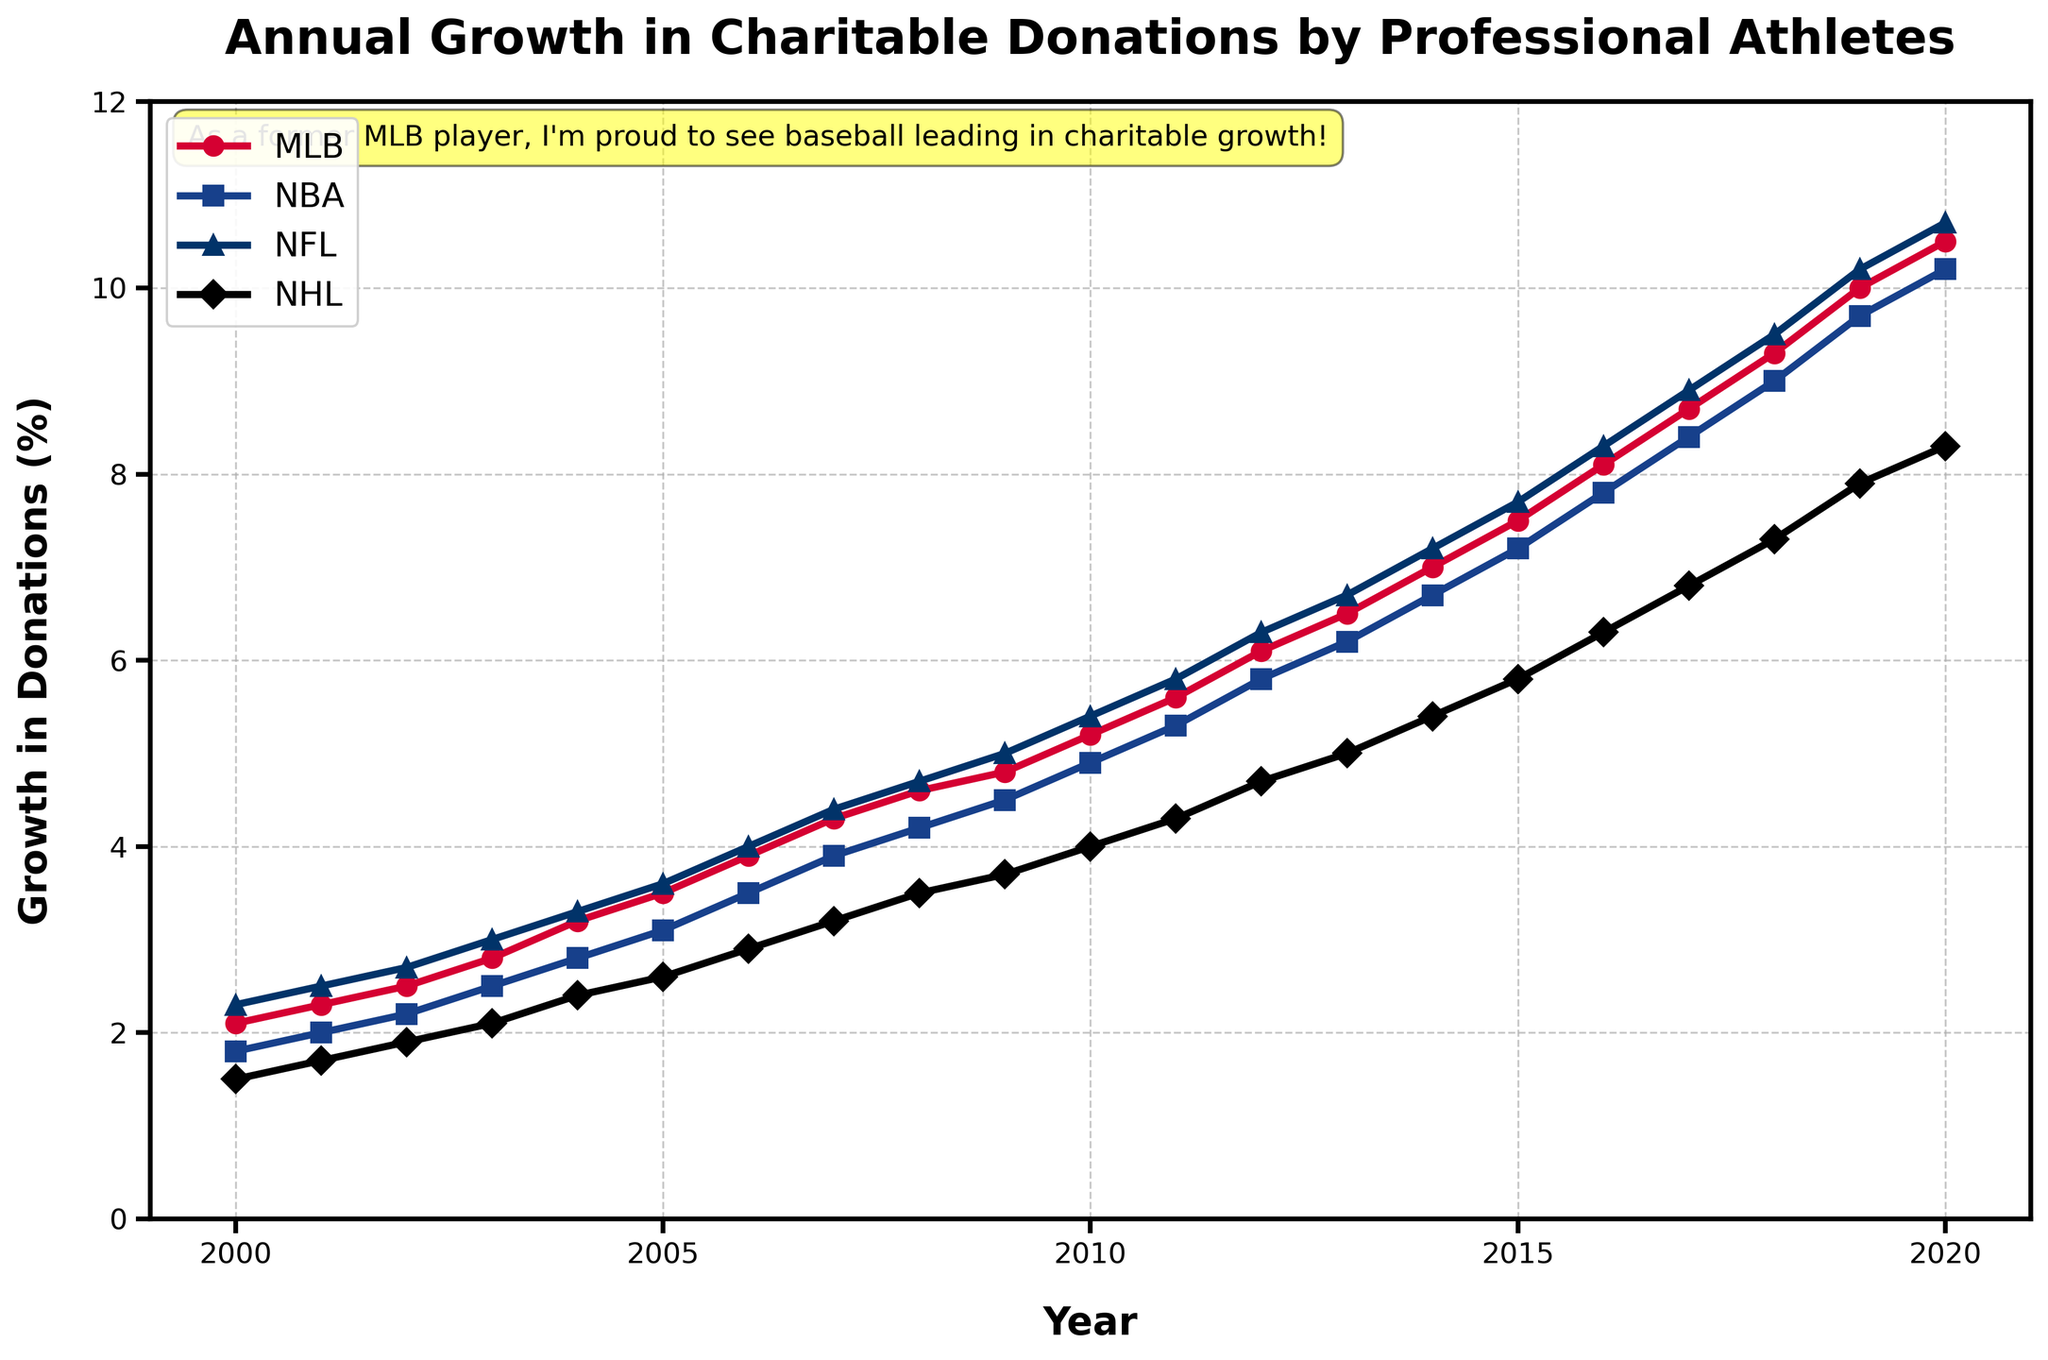what's the difference in charitable donations between MLB and NBA in 2020? To find the difference, subtract NBA's value from MLB's value in 2020. The MLB donations are 10.5% and NBA donations are 10.2%, so the difference is 10.5% - 10.2%.
Answer: 0.3% which league had the most significant growth in charitable donations from 2000 to 2020? Examine the difference between the 2020 value and the 2000 value for each league. MLB (10.5% - 2.1%), NBA (10.2% - 1.8%), NFL (10.7% - 2.3%), NHL (8.3% - 1.5%). The NFL has the highest growth.
Answer: NFL which two leagues had the closest donation growth percentages in 2010? Compare the donation values of all leagues in 2010. MLB (5.2%), NBA (4.9%), NFL (5.4%), NHL (4.0%). MLB and NFL have the closest percentages with a difference of 0.2%.
Answer: MLB and NFL what is the average growth in charitable donations for the NHL from 2000 to 2020? To find the average, sum up NHL's annual growth percentages from 2000 to 2020 and then divide by the number of years (21). (1.5+1.7+1.9+2.1+2.4+2.6+2.9+3.2+3.5+3.7+4.0+4.3+4.7+5.0+5.4+5.8+6.3+6.8+7.3+7.9+8.3)/21
Answer: 4.33 was there ever a year where the donation growth for all leagues crossed the 3% mark? Observe the lines for all leagues to see when they all pass the value of 3%. In the year 2005, the growth percentages for MLB, NBA, NFL, and NHL are 3.5%, 3.1%, 3.6%, and 2.6%, respectively. The closest year is 2006 when the lowest value (NHL) reaches 2.9%.
Answer: No which league was consistently the lowest in charitable donations growth from 2000 to 2020? Track the position of each league's line over the years. NHL has the lowest values consistently from 2000 to 2020.
Answer: NHL what was the overall trend observed for the NBA in terms of charitable donations from 2000 to 2020? Examine the NBA's line trend from 2000 to 2020. The trend is consistently upward, indicating a steady increase in charitable donations.
Answer: Increasing did the donations growth for NFL ever fall below NBA's donations growth? Compare the NFL and NBA values year by year. NFL donations growth remained above NBA's growth in all years.
Answer: No how much did MLB donations grow from 2015 to 2020? Subtract the MLB donations value in 2015 from the value in 2020. MLB donations: 10.5% in 2020 and 7.5% in 2015. The growth is 10.5% - 7.5%.
Answer: 3% which year did the MLB donations surpass the 6% mark? Look at the MLB line to find when it first crosses 6%. In 2012, MLB growth reaches 6.1%.
Answer: 2012 